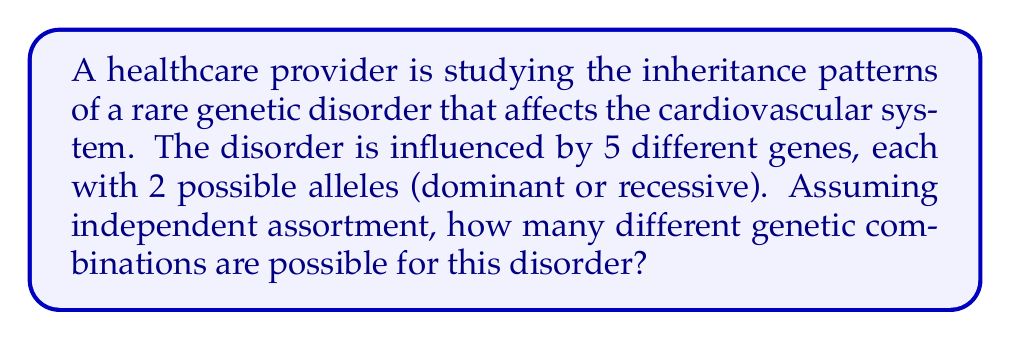Can you solve this math problem? To solve this problem, we'll use the multiplication principle of counting. Here's a step-by-step explanation:

1. We have 5 different genes influencing the disorder.
2. Each gene has 2 possible alleles (dominant or recessive).
3. For each gene, there are 3 possible genotype combinations:
   - Homozygous dominant (DD)
   - Heterozygous (Dd or dD)
   - Homozygous recessive (dd)

4. Therefore, for each gene, there are 3 possibilities.

5. Since we have 5 independent genes, we multiply the number of possibilities for each gene:

   $$ \text{Total combinations} = 3 \times 3 \times 3 \times 3 \times 3 $$

6. This can be written as an exponent:

   $$ \text{Total combinations} = 3^5 $$

7. Calculate the result:

   $$ 3^5 = 3 \times 3 \times 3 \times 3 \times 3 = 243 $$

Thus, there are 243 different genetic combinations possible for this disorder.
Answer: 243 